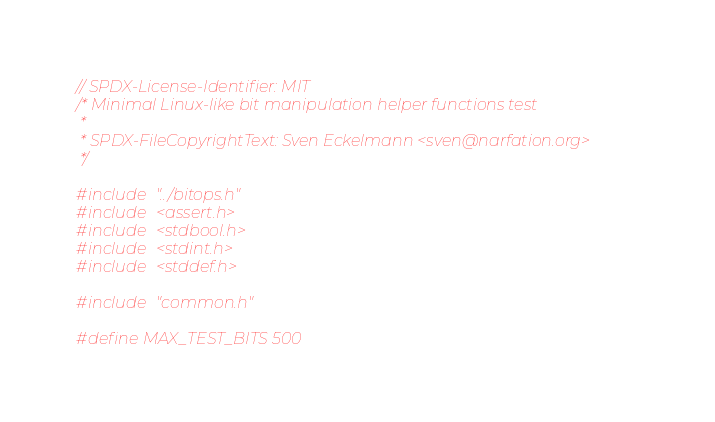Convert code to text. <code><loc_0><loc_0><loc_500><loc_500><_C_>// SPDX-License-Identifier: MIT
/* Minimal Linux-like bit manipulation helper functions test
 *
 * SPDX-FileCopyrightText: Sven Eckelmann <sven@narfation.org>
 */

#include "../bitops.h"
#include <assert.h>
#include <stdbool.h>
#include <stdint.h>
#include <stddef.h>

#include "common.h"

#define MAX_TEST_BITS 500</code> 